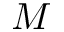Convert formula to latex. <formula><loc_0><loc_0><loc_500><loc_500>M</formula> 